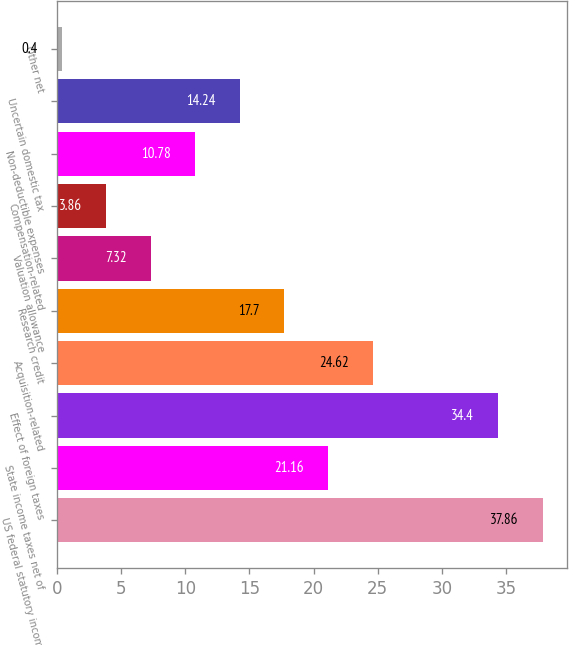<chart> <loc_0><loc_0><loc_500><loc_500><bar_chart><fcel>US federal statutory income<fcel>State income taxes net of<fcel>Effect of foreign taxes<fcel>Acquisition-related<fcel>Research credit<fcel>Valuation allowance<fcel>Compensation-related<fcel>Non-deductible expenses<fcel>Uncertain domestic tax<fcel>Other net<nl><fcel>37.86<fcel>21.16<fcel>34.4<fcel>24.62<fcel>17.7<fcel>7.32<fcel>3.86<fcel>10.78<fcel>14.24<fcel>0.4<nl></chart> 